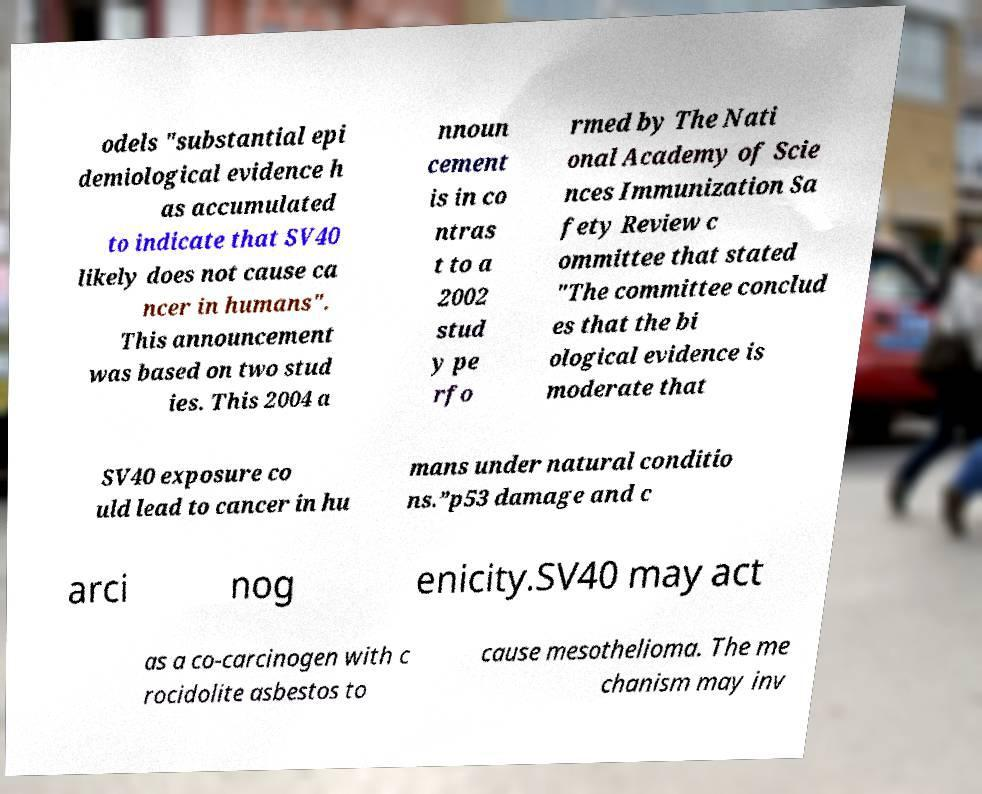There's text embedded in this image that I need extracted. Can you transcribe it verbatim? odels "substantial epi demiological evidence h as accumulated to indicate that SV40 likely does not cause ca ncer in humans". This announcement was based on two stud ies. This 2004 a nnoun cement is in co ntras t to a 2002 stud y pe rfo rmed by The Nati onal Academy of Scie nces Immunization Sa fety Review c ommittee that stated "The committee conclud es that the bi ological evidence is moderate that SV40 exposure co uld lead to cancer in hu mans under natural conditio ns.”p53 damage and c arci nog enicity.SV40 may act as a co-carcinogen with c rocidolite asbestos to cause mesothelioma. The me chanism may inv 